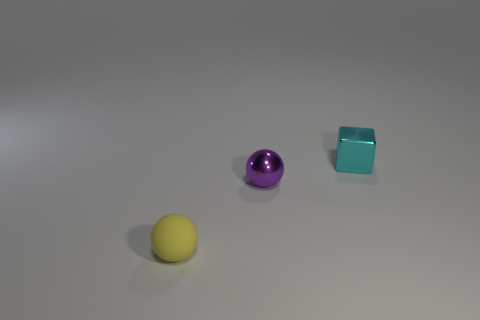Is there anything else that has the same material as the small yellow ball?
Your answer should be very brief. No. What is the shape of the shiny object that is the same size as the cyan metal cube?
Provide a short and direct response. Sphere. Are there any small metallic things behind the purple shiny object?
Your answer should be very brief. Yes. Are there any yellow objects that have the same shape as the tiny purple thing?
Make the answer very short. Yes. Do the object that is left of the small metallic sphere and the small shiny thing that is behind the metal ball have the same shape?
Provide a short and direct response. No. Is there another rubber thing that has the same size as the purple object?
Provide a short and direct response. Yes. Are there the same number of small metal spheres that are right of the small purple shiny ball and tiny blocks left of the yellow rubber object?
Make the answer very short. Yes. Is the sphere behind the tiny yellow rubber object made of the same material as the tiny thing behind the purple sphere?
Make the answer very short. Yes. What is the small purple sphere made of?
Offer a very short reply. Metal. Does the tiny rubber object have the same color as the tiny cube?
Offer a terse response. No. 